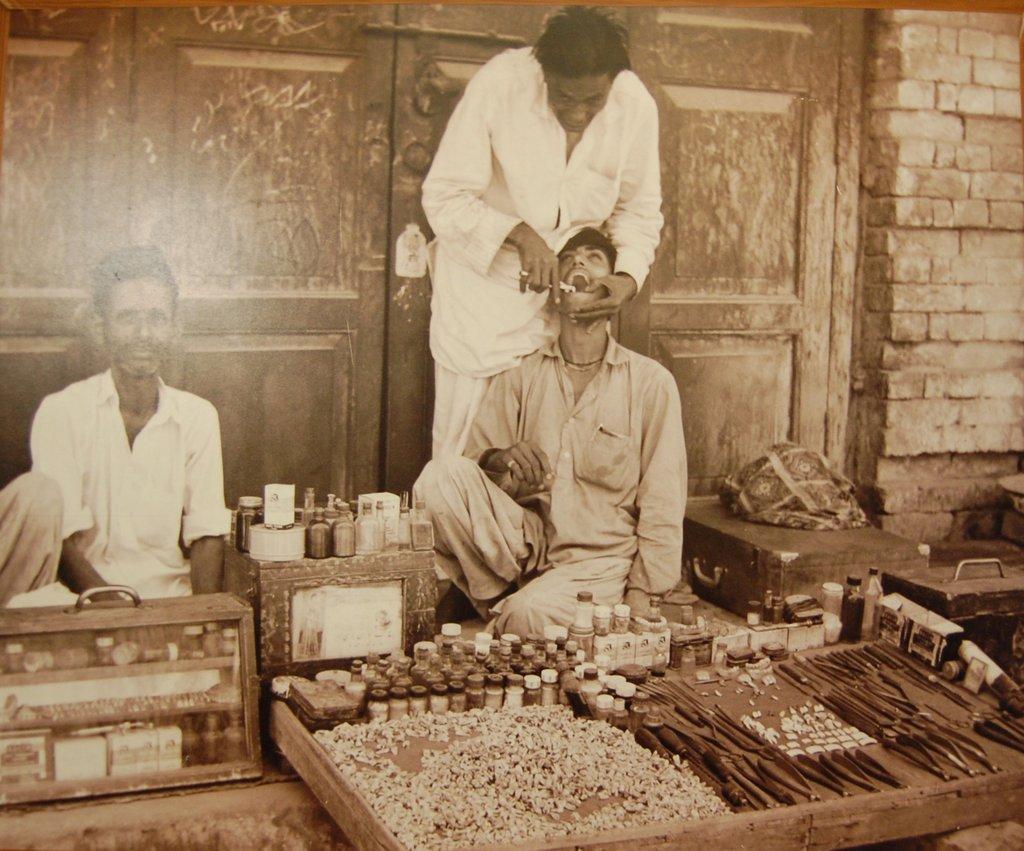Can you describe this image briefly? On the left side, there is a person in white color shirt, sitting. Beside him, there are bottles arranged on the surface of a box and there is another box is on the floor. On the right side, there are sticks, teeth and bottles arranged on a wooden object. Beside this object, there is a person in white color dress, treating another person. In the background, there is a wooden door attached to the brick wall. 